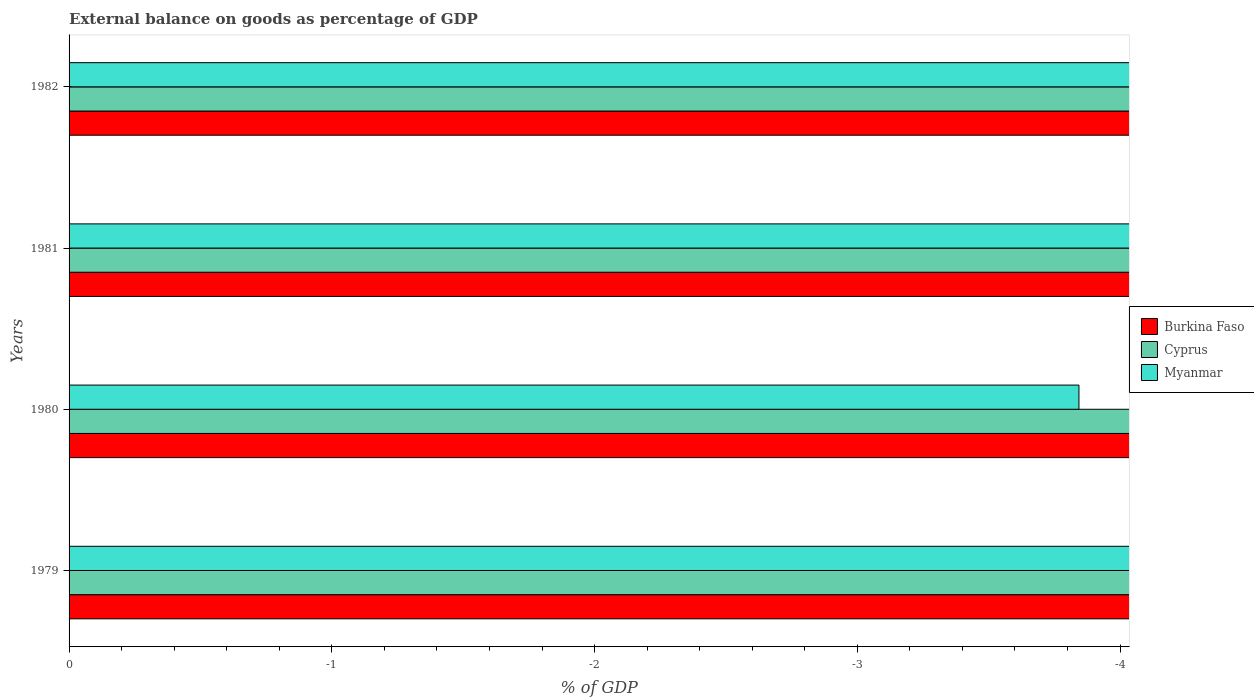Are the number of bars per tick equal to the number of legend labels?
Keep it short and to the point. No. Are the number of bars on each tick of the Y-axis equal?
Provide a succinct answer. Yes. How many bars are there on the 1st tick from the bottom?
Give a very brief answer. 0. What is the external balance on goods as percentage of GDP in Cyprus in 1981?
Give a very brief answer. 0. Across all years, what is the minimum external balance on goods as percentage of GDP in Burkina Faso?
Provide a short and direct response. 0. What is the total external balance on goods as percentage of GDP in Cyprus in the graph?
Offer a terse response. 0. What is the average external balance on goods as percentage of GDP in Burkina Faso per year?
Your answer should be compact. 0. In how many years, is the external balance on goods as percentage of GDP in Myanmar greater than -2.6 %?
Keep it short and to the point. 0. In how many years, is the external balance on goods as percentage of GDP in Myanmar greater than the average external balance on goods as percentage of GDP in Myanmar taken over all years?
Your response must be concise. 0. How many years are there in the graph?
Keep it short and to the point. 4. Are the values on the major ticks of X-axis written in scientific E-notation?
Offer a terse response. No. Does the graph contain grids?
Provide a short and direct response. No. Where does the legend appear in the graph?
Provide a succinct answer. Center right. How many legend labels are there?
Ensure brevity in your answer.  3. How are the legend labels stacked?
Provide a succinct answer. Vertical. What is the title of the graph?
Offer a terse response. External balance on goods as percentage of GDP. Does "Uzbekistan" appear as one of the legend labels in the graph?
Your answer should be very brief. No. What is the label or title of the X-axis?
Your answer should be very brief. % of GDP. What is the % of GDP in Myanmar in 1979?
Provide a short and direct response. 0. What is the % of GDP in Burkina Faso in 1980?
Make the answer very short. 0. What is the % of GDP of Cyprus in 1980?
Offer a terse response. 0. What is the % of GDP of Myanmar in 1980?
Your answer should be very brief. 0. What is the % of GDP in Cyprus in 1982?
Your answer should be compact. 0. What is the average % of GDP of Cyprus per year?
Give a very brief answer. 0. 